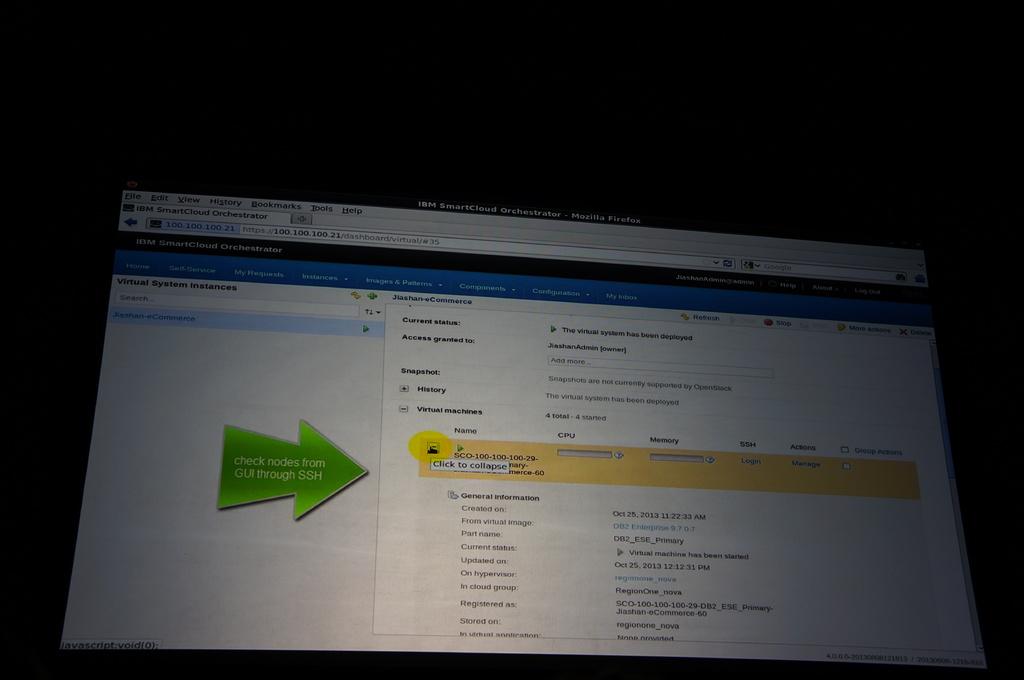What must you check according to the green arrow?
Make the answer very short. Nodes from gui through ssh. What does the green arrow read?
Offer a very short reply. Check nodes from gui through ssh. 